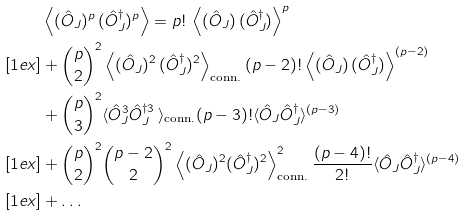Convert formula to latex. <formula><loc_0><loc_0><loc_500><loc_500>& \left \langle ( \hat { O } _ { J } ) ^ { p } \, ( \hat { O } _ { J } ^ { \dagger } ) ^ { p } \right \rangle = p ! \, \left \langle ( \hat { O } _ { J } ) \, ( \hat { O } _ { J } ^ { \dagger } ) \right \rangle ^ { p } \\ [ 1 e x ] & + \binom { p } { 2 } ^ { 2 } \left \langle ( \hat { O } _ { J } ) ^ { 2 } \, ( \hat { O } _ { J } ^ { \dagger } ) ^ { 2 } \right \rangle _ { \text {conn.} } ( p - 2 ) ! \left \langle ( \hat { O } _ { J } ) \, ( \hat { O } _ { J } ^ { \dagger } ) \right \rangle ^ { ( p - 2 ) } \\ & + \binom { p } { 3 } ^ { 2 } \langle \hat { O } _ { J } ^ { 3 } \hat { O } _ { J } ^ { \dagger 3 } \, \rangle _ { \text {conn.} } ( p - 3 ) ! \langle \hat { O } _ { J } \hat { O } _ { J } ^ { \dagger } \rangle ^ { ( p - 3 ) } \\ [ 1 e x ] & + \binom { p } { 2 } ^ { 2 } \binom { p - 2 } { 2 } ^ { 2 } \left \langle ( \hat { O } _ { J } ) ^ { 2 } ( \hat { O } _ { J } ^ { \dagger } ) ^ { 2 } \right \rangle _ { \text {conn.} } ^ { 2 } \frac { ( p - 4 ) ! } { 2 ! } \langle \hat { O } _ { J } \hat { O } _ { J } ^ { \dagger } \rangle ^ { ( p - 4 ) } \\ [ 1 e x ] & + \dots</formula> 